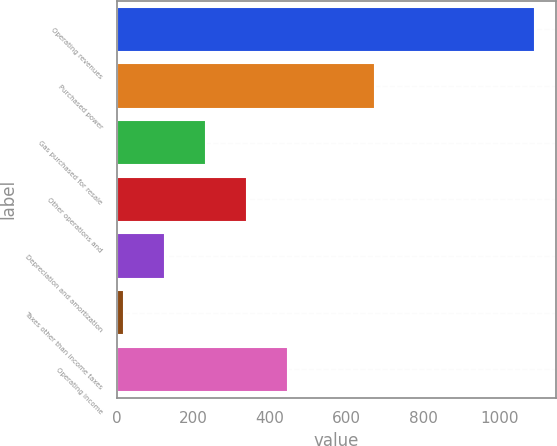Convert chart to OTSL. <chart><loc_0><loc_0><loc_500><loc_500><bar_chart><fcel>Operating revenues<fcel>Purchased power<fcel>Gas purchased for resale<fcel>Other operations and<fcel>Depreciation and amortization<fcel>Taxes other than income taxes<fcel>Operating income<nl><fcel>1091<fcel>674<fcel>234.2<fcel>341.3<fcel>127.1<fcel>20<fcel>448.4<nl></chart> 